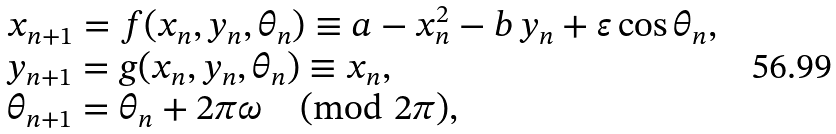Convert formula to latex. <formula><loc_0><loc_0><loc_500><loc_500>\begin{array} { l l l } x _ { n + 1 } = f ( x _ { n } , y _ { n } , \theta _ { n } ) \equiv a - x _ { n } ^ { 2 } - b \, y _ { n } + \varepsilon \cos { \theta _ { n } } , \\ y _ { n + 1 } = g ( x _ { n } , y _ { n } , \theta _ { n } ) \equiv x _ { n } , \\ \theta _ { n + 1 } = \theta _ { n } + 2 \pi \omega \pmod { 2 \pi } , \end{array}</formula> 